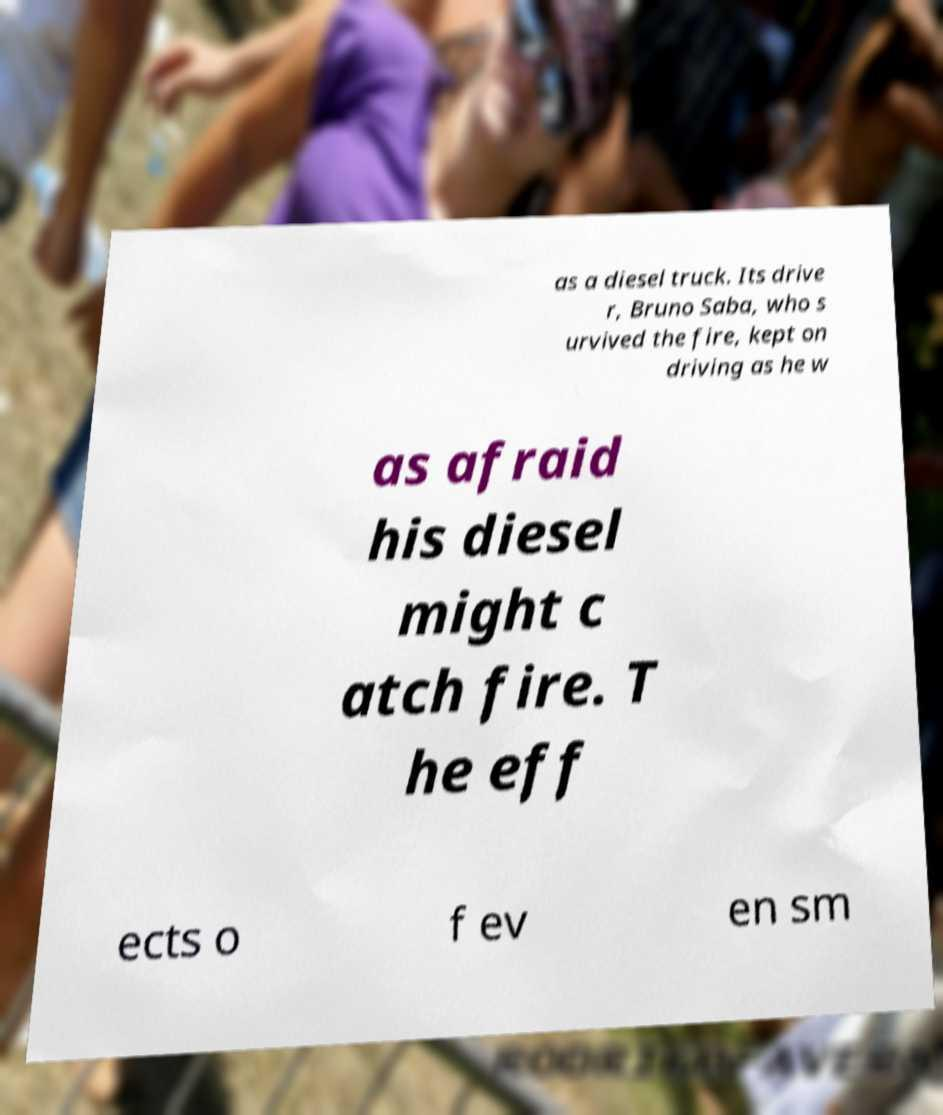Can you accurately transcribe the text from the provided image for me? as a diesel truck. Its drive r, Bruno Saba, who s urvived the fire, kept on driving as he w as afraid his diesel might c atch fire. T he eff ects o f ev en sm 